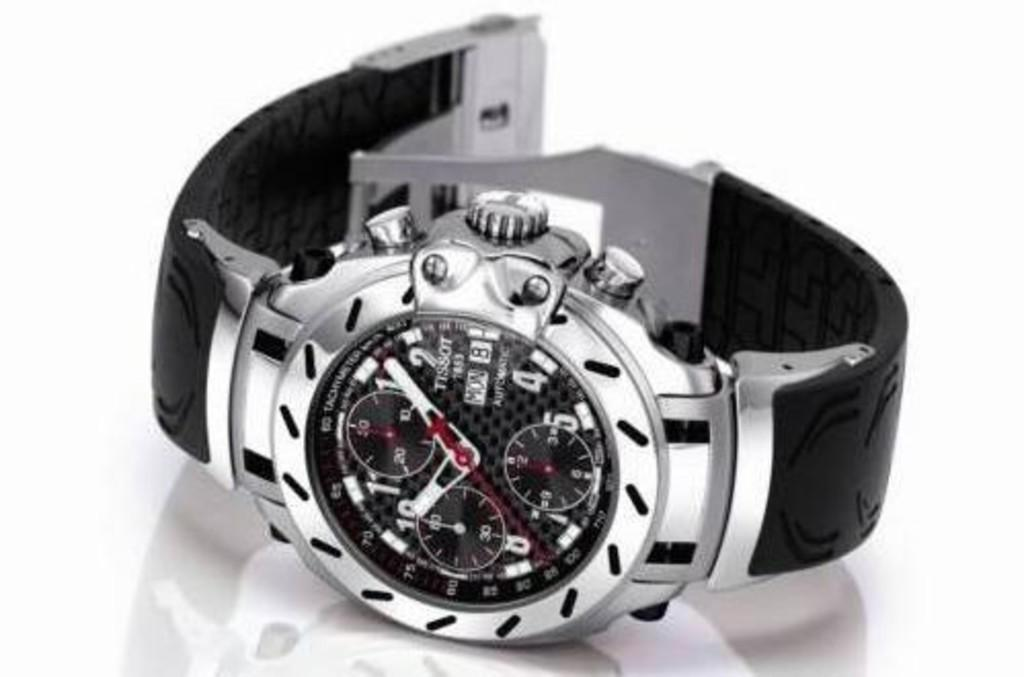<image>
Render a clear and concise summary of the photo. a Tissot watch with date Mon 8 is on a white table 